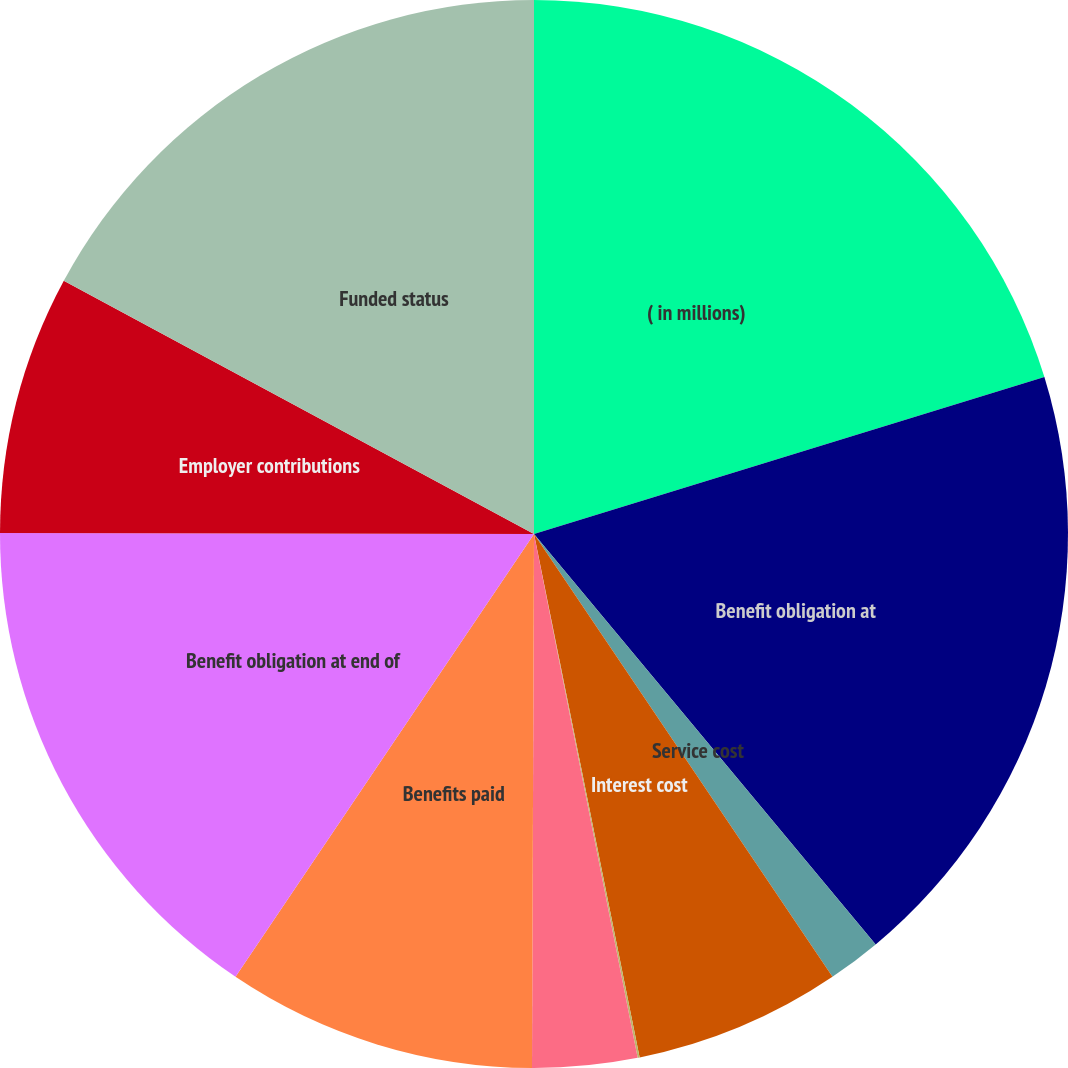Convert chart to OTSL. <chart><loc_0><loc_0><loc_500><loc_500><pie_chart><fcel>( in millions)<fcel>Benefit obligation at<fcel>Service cost<fcel>Interest cost<fcel>Plan participants'<fcel>Actuarial loss (gain)<fcel>Benefits paid<fcel>Benefit obligation at end of<fcel>Employer contributions<fcel>Funded status<nl><fcel>20.25%<fcel>18.7%<fcel>1.61%<fcel>6.27%<fcel>0.06%<fcel>3.17%<fcel>9.38%<fcel>15.59%<fcel>7.83%<fcel>17.14%<nl></chart> 